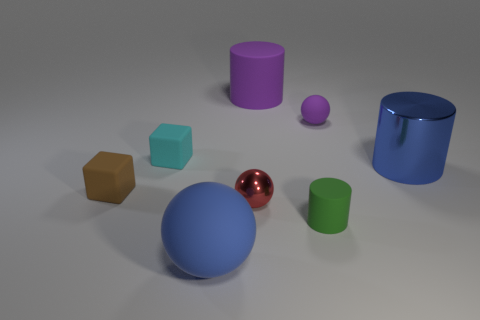What size is the object that is the same color as the big matte cylinder?
Offer a terse response. Small. Is there anything else that has the same color as the tiny cylinder?
Ensure brevity in your answer.  No. The object that is in front of the green thing that is in front of the small brown thing is what color?
Give a very brief answer. Blue. What is the material of the blue thing that is in front of the small sphere to the left of the ball that is on the right side of the big purple cylinder?
Your answer should be compact. Rubber. What number of green rubber cylinders are the same size as the green matte thing?
Offer a very short reply. 0. What is the material of the tiny thing that is to the left of the small purple rubber ball and on the right side of the red shiny object?
Give a very brief answer. Rubber. There is a small cyan matte thing; what number of brown cubes are on the left side of it?
Offer a very short reply. 1. Do the large blue rubber thing and the metallic thing in front of the brown thing have the same shape?
Offer a very short reply. Yes. Is there another small matte object that has the same shape as the cyan rubber object?
Keep it short and to the point. Yes. What shape is the object behind the sphere that is on the right side of the red metal object?
Offer a terse response. Cylinder. 